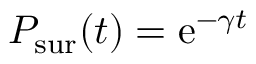<formula> <loc_0><loc_0><loc_500><loc_500>P _ { s u r } ( t ) = e ^ { - \gamma t }</formula> 